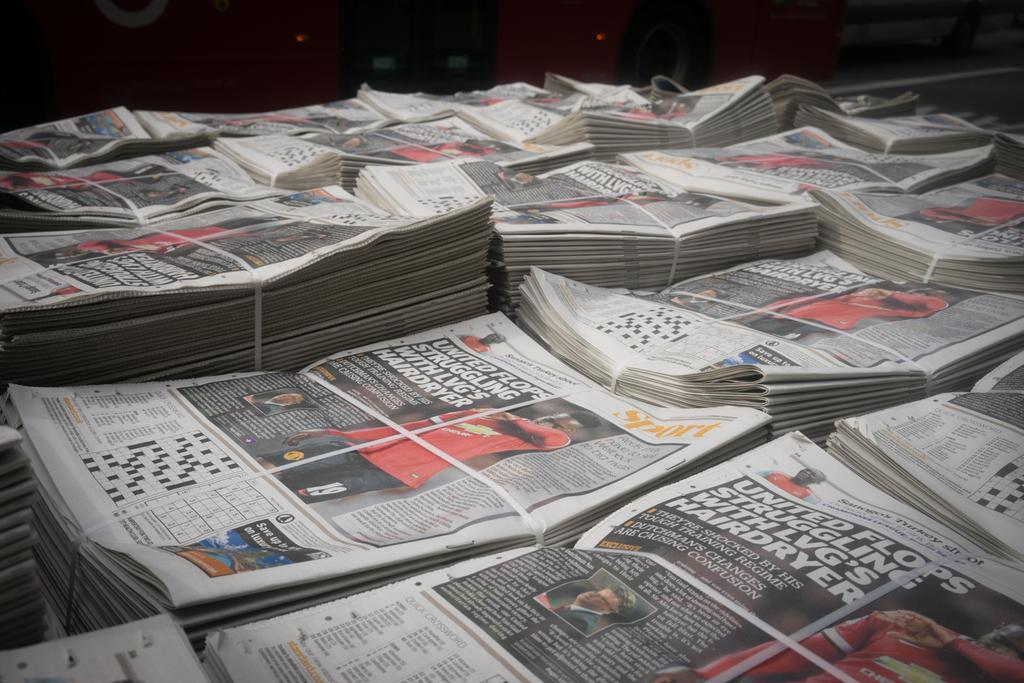<image>
Render a clear and concise summary of the photo. a newspaper with the words 'united flops' on it 